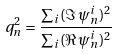Convert formula to latex. <formula><loc_0><loc_0><loc_500><loc_500>q _ { n } ^ { 2 } = \frac { \sum _ { i } ( \Im \, \psi _ { n } ^ { i } ) ^ { 2 } } { \sum _ { i } ( \Re \, \psi _ { n } ^ { i } ) ^ { 2 } }</formula> 